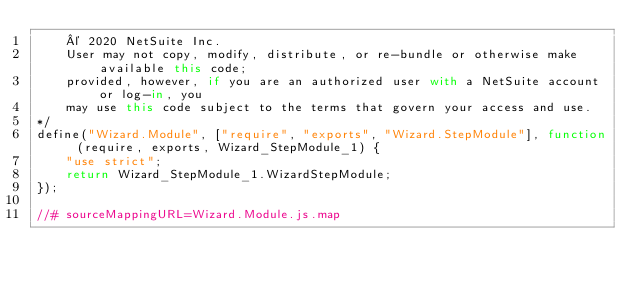<code> <loc_0><loc_0><loc_500><loc_500><_JavaScript_>    © 2020 NetSuite Inc.
    User may not copy, modify, distribute, or re-bundle or otherwise make available this code;
    provided, however, if you are an authorized user with a NetSuite account or log-in, you
    may use this code subject to the terms that govern your access and use.
*/
define("Wizard.Module", ["require", "exports", "Wizard.StepModule"], function (require, exports, Wizard_StepModule_1) {
    "use strict";
    return Wizard_StepModule_1.WizardStepModule;
});

//# sourceMappingURL=Wizard.Module.js.map
</code> 